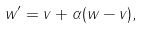<formula> <loc_0><loc_0><loc_500><loc_500>w ^ { \prime } = v + \alpha ( w - v ) ,</formula> 